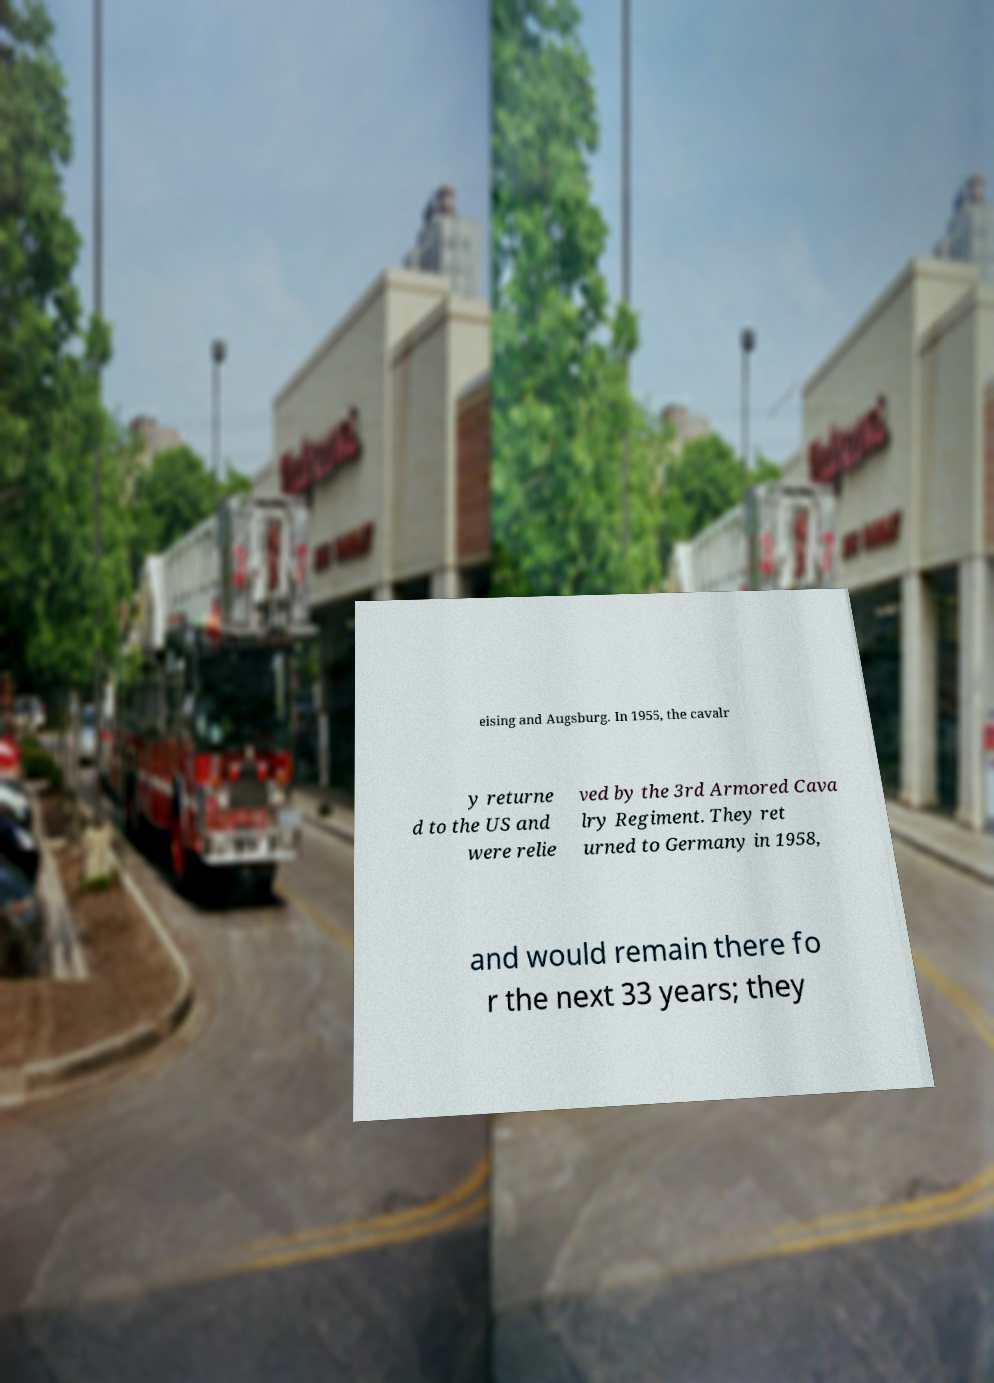Can you accurately transcribe the text from the provided image for me? eising and Augsburg. In 1955, the cavalr y returne d to the US and were relie ved by the 3rd Armored Cava lry Regiment. They ret urned to Germany in 1958, and would remain there fo r the next 33 years; they 